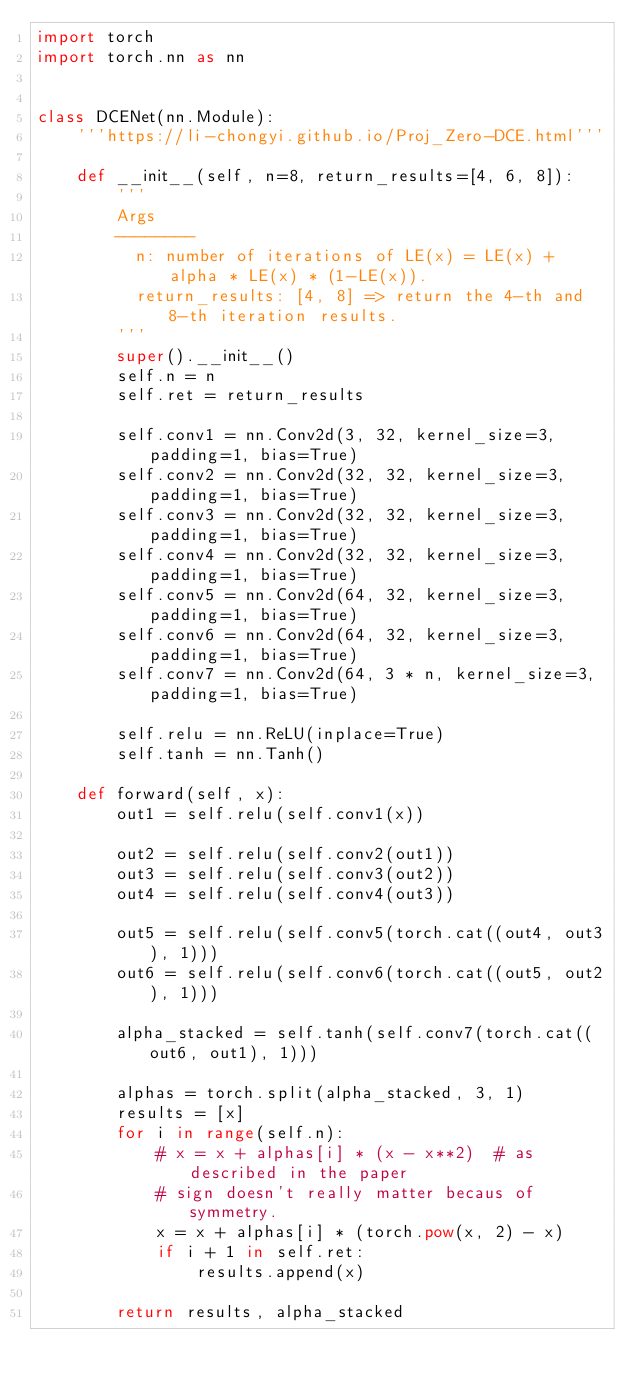<code> <loc_0><loc_0><loc_500><loc_500><_Python_>import torch
import torch.nn as nn


class DCENet(nn.Module):
    '''https://li-chongyi.github.io/Proj_Zero-DCE.html'''

    def __init__(self, n=8, return_results=[4, 6, 8]):
        '''
        Args
        --------
          n: number of iterations of LE(x) = LE(x) + alpha * LE(x) * (1-LE(x)).
          return_results: [4, 8] => return the 4-th and 8-th iteration results.
        '''
        super().__init__()
        self.n = n
        self.ret = return_results

        self.conv1 = nn.Conv2d(3, 32, kernel_size=3, padding=1, bias=True)
        self.conv2 = nn.Conv2d(32, 32, kernel_size=3, padding=1, bias=True)
        self.conv3 = nn.Conv2d(32, 32, kernel_size=3, padding=1, bias=True)
        self.conv4 = nn.Conv2d(32, 32, kernel_size=3, padding=1, bias=True)
        self.conv5 = nn.Conv2d(64, 32, kernel_size=3, padding=1, bias=True)
        self.conv6 = nn.Conv2d(64, 32, kernel_size=3, padding=1, bias=True)
        self.conv7 = nn.Conv2d(64, 3 * n, kernel_size=3, padding=1, bias=True)

        self.relu = nn.ReLU(inplace=True)
        self.tanh = nn.Tanh()

    def forward(self, x):
        out1 = self.relu(self.conv1(x))

        out2 = self.relu(self.conv2(out1))
        out3 = self.relu(self.conv3(out2))
        out4 = self.relu(self.conv4(out3))

        out5 = self.relu(self.conv5(torch.cat((out4, out3), 1)))
        out6 = self.relu(self.conv6(torch.cat((out5, out2), 1)))

        alpha_stacked = self.tanh(self.conv7(torch.cat((out6, out1), 1)))

        alphas = torch.split(alpha_stacked, 3, 1)
        results = [x]
        for i in range(self.n):
            # x = x + alphas[i] * (x - x**2)  # as described in the paper
            # sign doesn't really matter becaus of symmetry.
            x = x + alphas[i] * (torch.pow(x, 2) - x)
            if i + 1 in self.ret:
                results.append(x)

        return results, alpha_stacked
</code> 